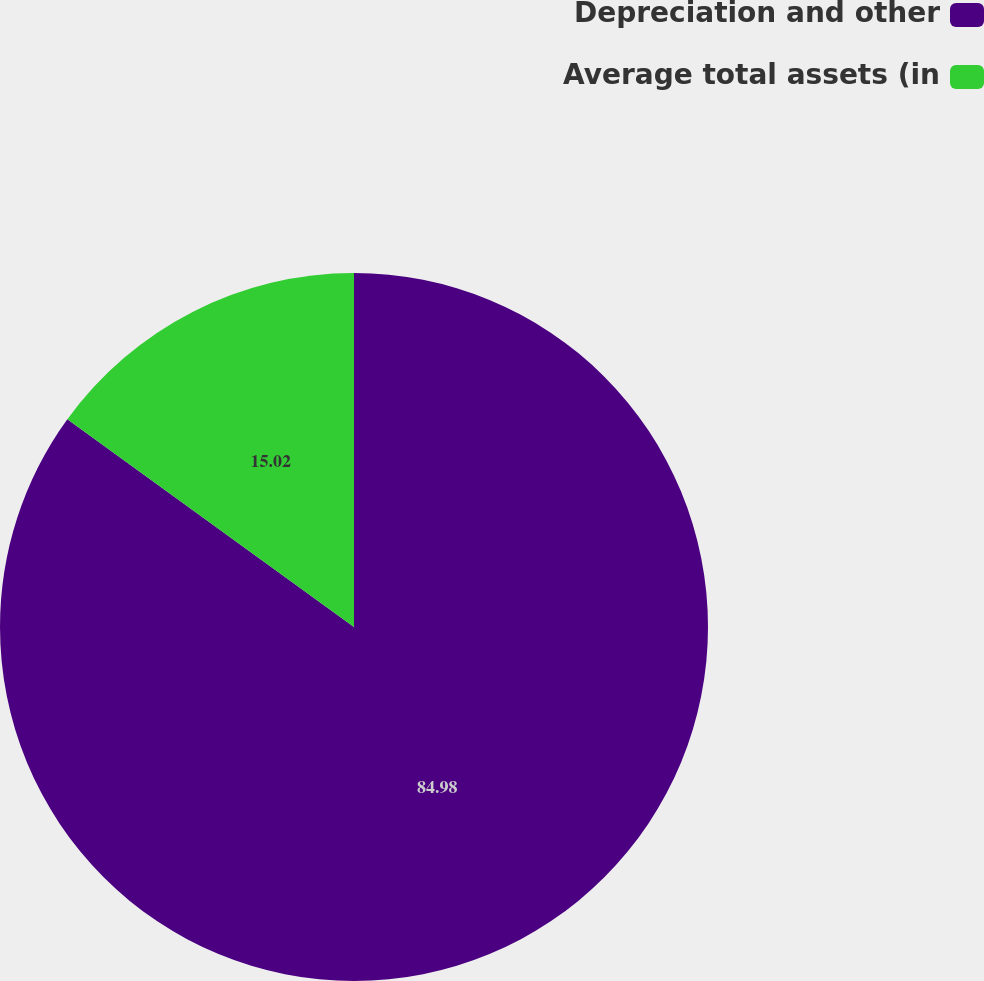Convert chart. <chart><loc_0><loc_0><loc_500><loc_500><pie_chart><fcel>Depreciation and other<fcel>Average total assets (in<nl><fcel>84.98%<fcel>15.02%<nl></chart> 